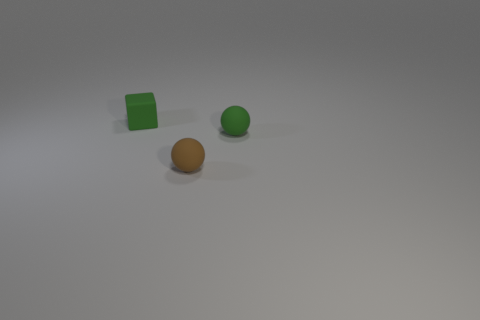What can we deduce about the setting these objects are in? These objects are on a plain, untextured surface, likely indoors given the control over lighting and the lack of any environmental features or distractions. 